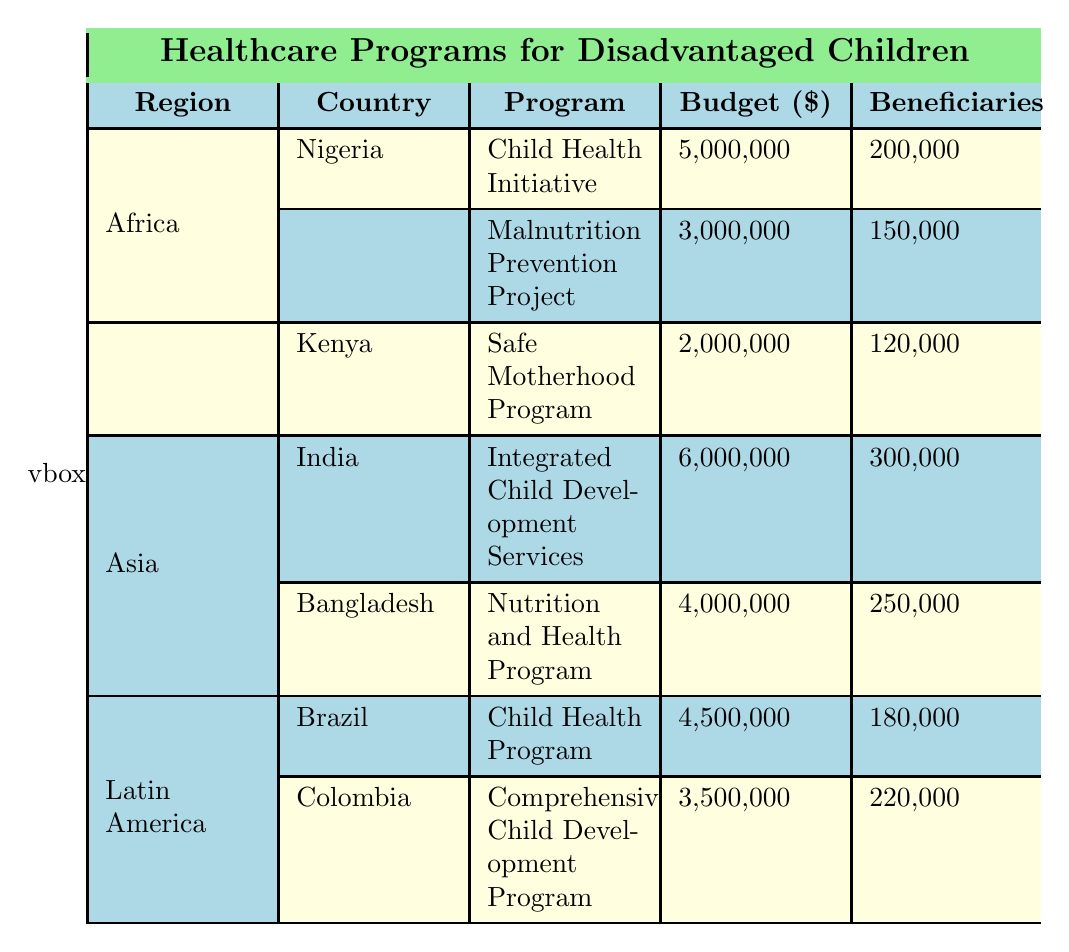What is the budget for the Child Health Initiative in Nigeria? The budget for the Child Health Initiative in Nigeria is listed directly under the "Budget" column corresponding to Nigeria and that program. It is 5,000,000.
Answer: 5,000,000 How many beneficiaries are served by the Nutrition and Health Program in Bangladesh? The number of beneficiaries served by the Nutrition and Health Program can be found in the "Beneficiaries" column next to Bangladesh and that specific program. It is 250,000.
Answer: 250,000 Which region has the highest total budget for healthcare programs targeted at disadvantaged children? To determine which region has the highest total budget, we need to sum the budgets for all programs in each region. In Africa: 5,000,000 + 3,000,000 + 2,000,000 = 10,000,000. In Asia: 6,000,000 + 4,000,000 = 10,000,000. In Latin America: 4,500,000 + 3,500,000 = 8,000,000. Thus, Africa and Asia tie for the highest total budget at 10,000,000.
Answer: Africa and Asia Is there a program in Kenya that focuses on child nutrition? Looking at the programs listed under Kenya, the only program mentioned is the Safe Motherhood Program which does not focus on child nutrition. Therefore, the answer is no.
Answer: No What is the total number of beneficiaries for all programs in Latin America? To find the total number of beneficiaries for Latin America, we sum the number of beneficiaries for the Child Health Program in Brazil (180,000) and the Comprehensive Child Development Program in Colombia (220,000). The total is 180,000 + 220,000 = 400,000.
Answer: 400,000 Which program in India serves the largest number of beneficiaries? In the table under Asia for India, the only program listed is the Integrated Child Development Services, which serves 300,000 beneficiaries. Hence, this is the largest number among Indian programs.
Answer: Integrated Child Development Services What percentage of the overall budget in Africa is allocated to the Malnutrition Prevention Project? The total budget for Africa is calculated as 10,000,000. The budget for the Malnutrition Prevention Project is 3,000,000. To find the percentage: (3,000,000 / 10,000,000) * 100 = 30%. Thus, 30% of the total budget in Africa is dedicated to this project.
Answer: 30% Do any programs in the table specifically target infectious diseases? The only program specifically mentioned as targeting infectious diseases is the Child Health Program in Brazil. Therefore, the answer is yes.
Answer: Yes What is the average budget for healthcare programs in Asia? In Asia, the budgets are 6,000,000 and 4,000,000 for their respective programs. To find the average, we first sum these: 6,000,000 + 4,000,000 = 10,000,000. Then, we divide by the number of programs, which is 2. Thus, the average budget is 10,000,000 / 2 = 5,000,000.
Answer: 5,000,000 